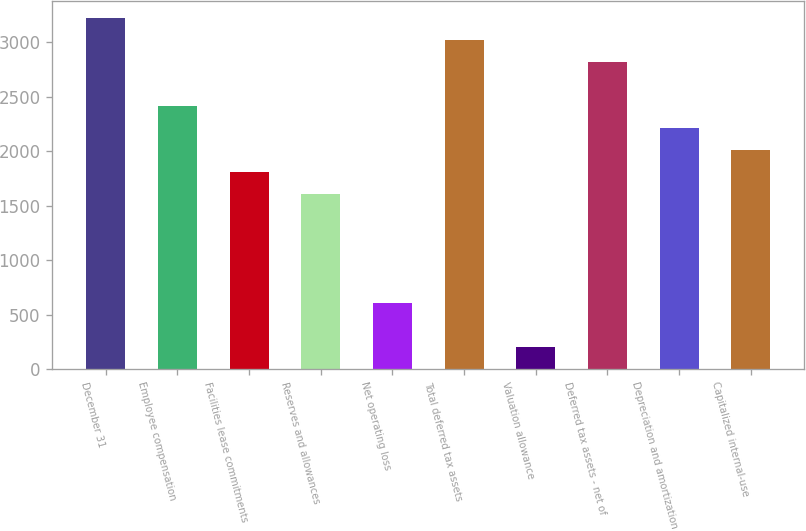<chart> <loc_0><loc_0><loc_500><loc_500><bar_chart><fcel>December 31<fcel>Employee compensation<fcel>Facilities lease commitments<fcel>Reserves and allowances<fcel>Net operating loss<fcel>Total deferred tax assets<fcel>Valuation allowance<fcel>Deferred tax assets - net of<fcel>Depreciation and amortization<fcel>Capitalized internal-use<nl><fcel>3219.6<fcel>2415.2<fcel>1811.9<fcel>1610.8<fcel>605.3<fcel>3018.5<fcel>203.1<fcel>2817.4<fcel>2214.1<fcel>2013<nl></chart> 